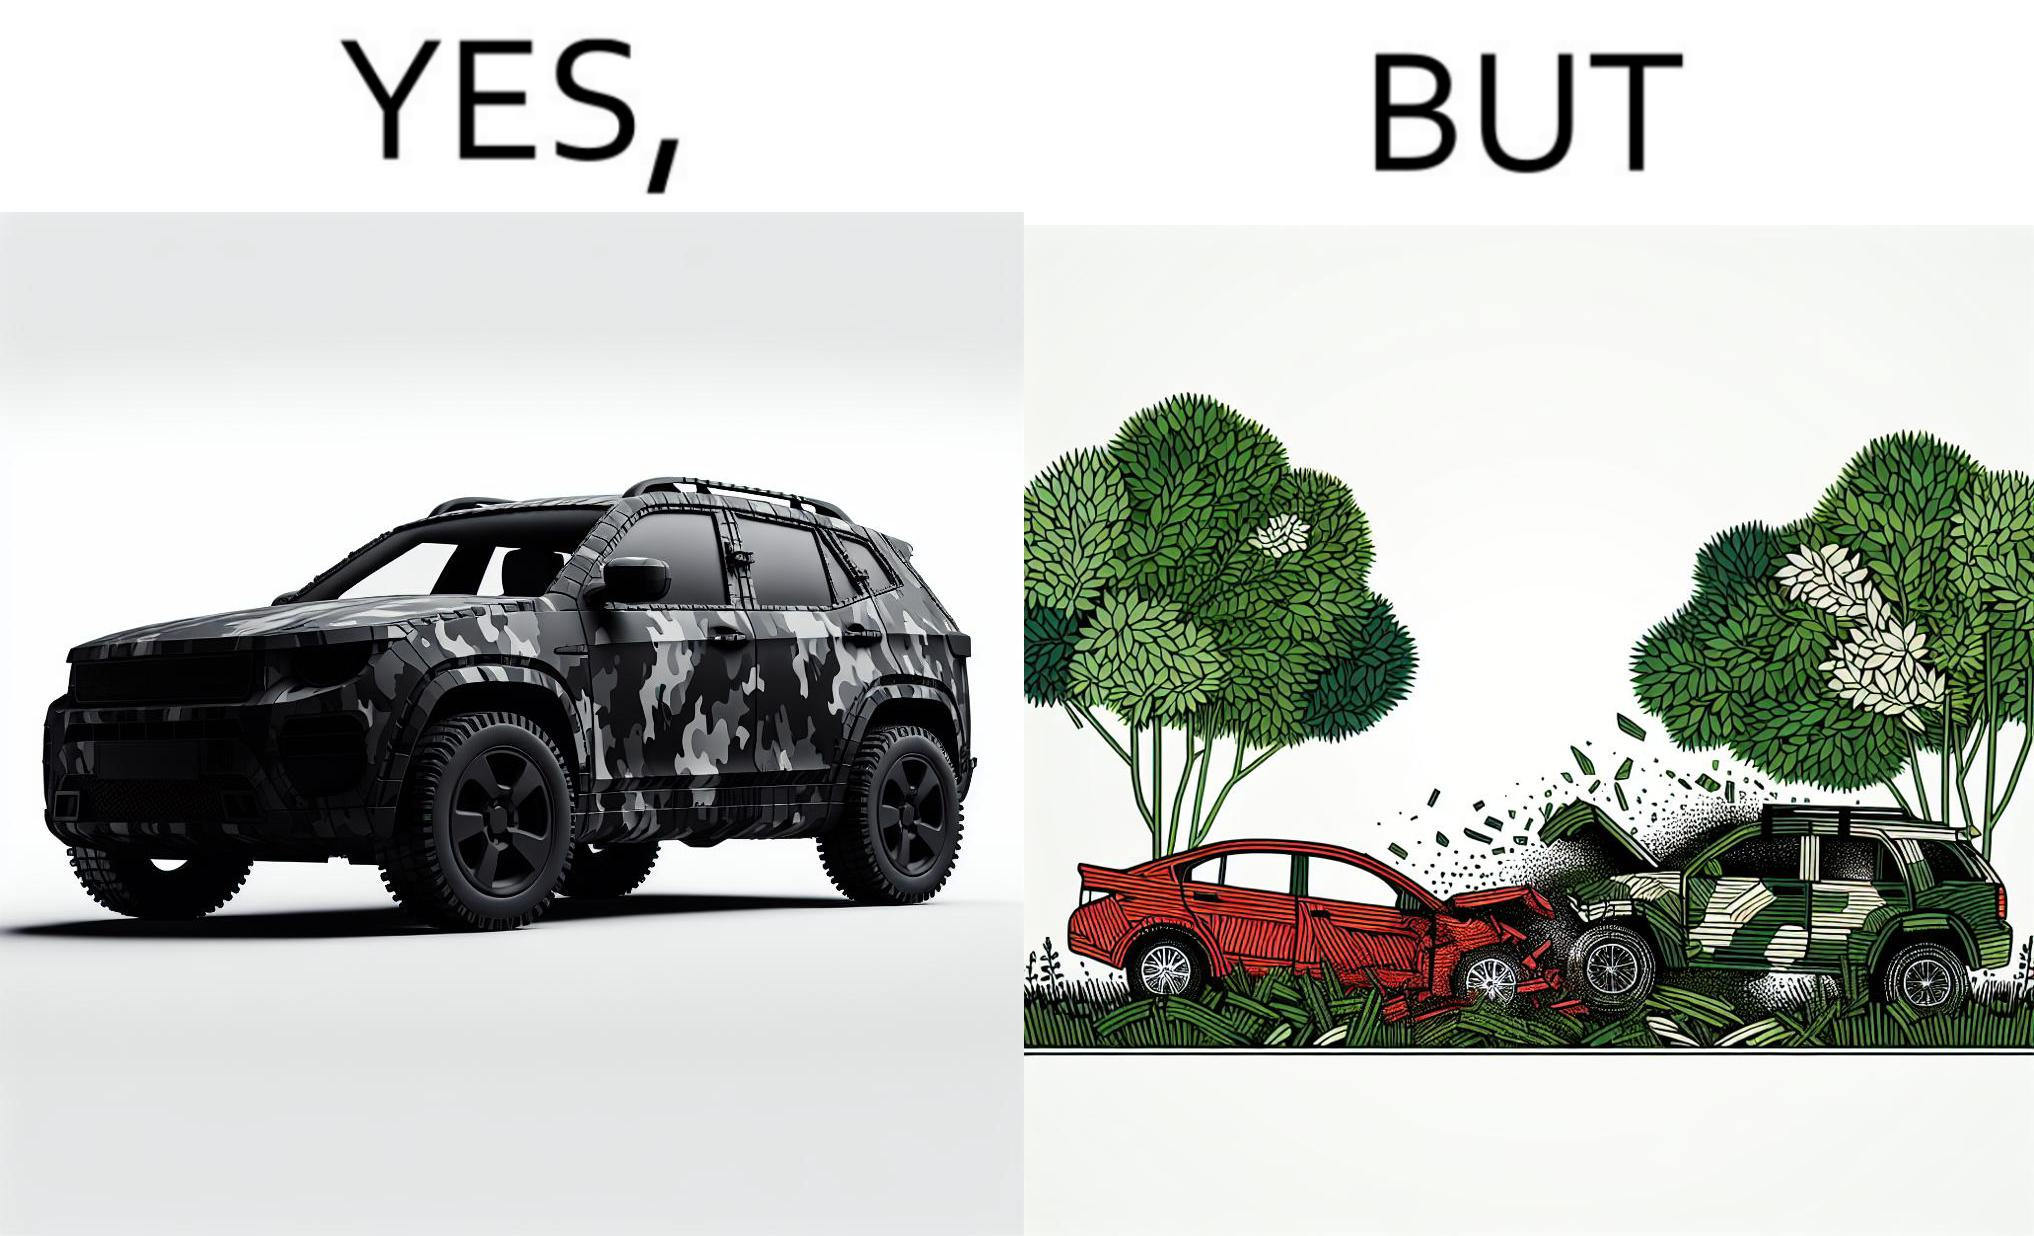Explain why this image is satirical. The image is ironic, because in the left image a car is painted in camouflage color but in the right image the same car is getting involved in accident to due to its color as other drivers face difficulty in recognizing the colors 